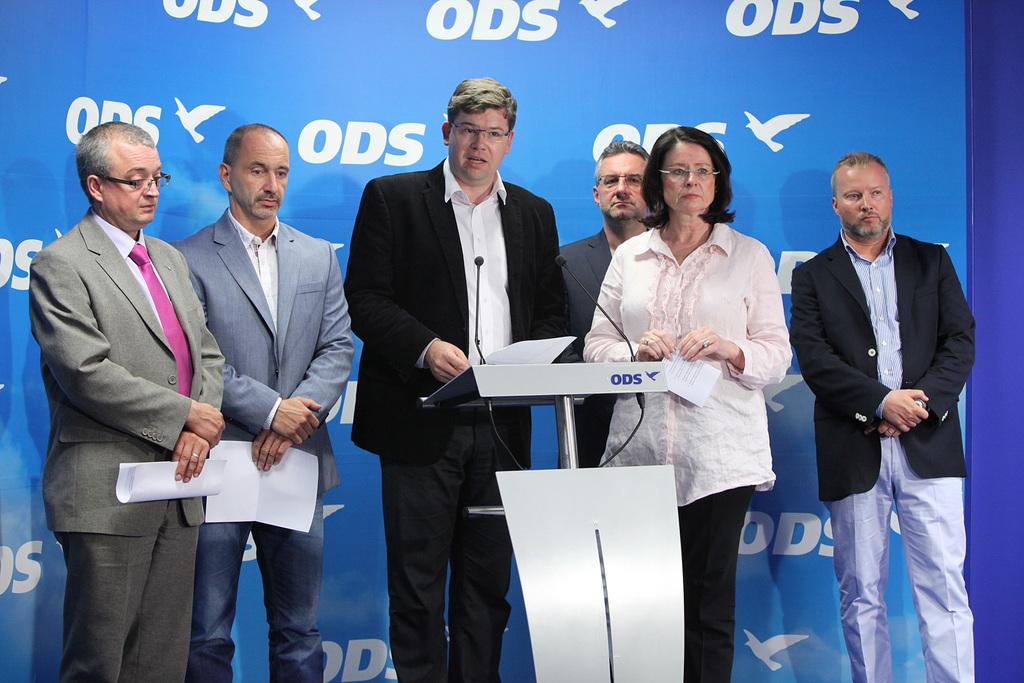What are the people in the image holding? The people in the image are holding papers. What position are the people in? The people are standing. What can be seen on the papers or in the image? There is text visible in the image. What type of images are present in the image? There are images of birds in the image. What color is the background of the image? The background is blue. What type of watch is the bird wearing in the image? There are no watches or birds wearing watches in the image. 